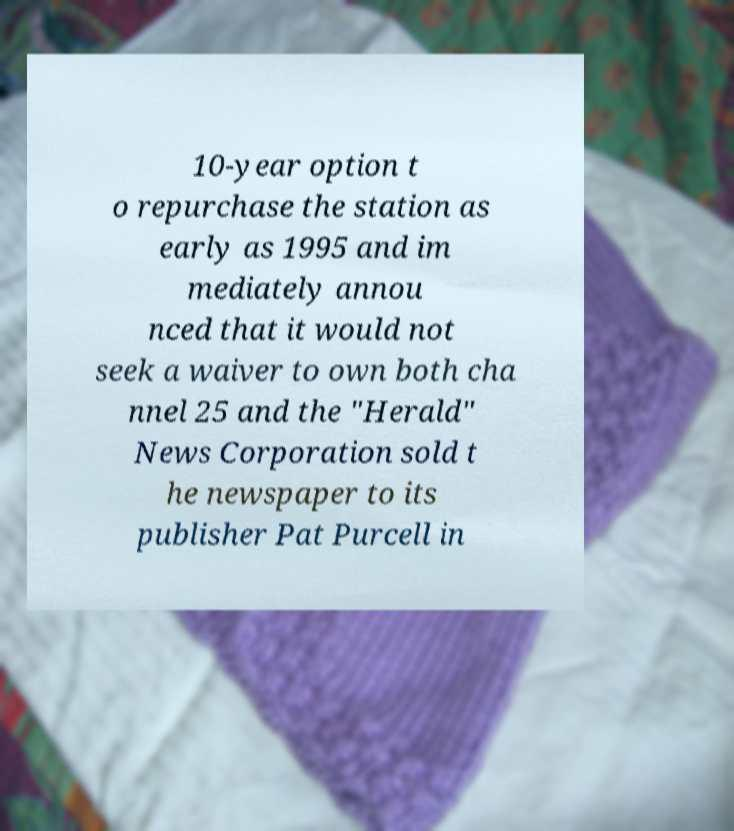I need the written content from this picture converted into text. Can you do that? 10-year option t o repurchase the station as early as 1995 and im mediately annou nced that it would not seek a waiver to own both cha nnel 25 and the "Herald" News Corporation sold t he newspaper to its publisher Pat Purcell in 